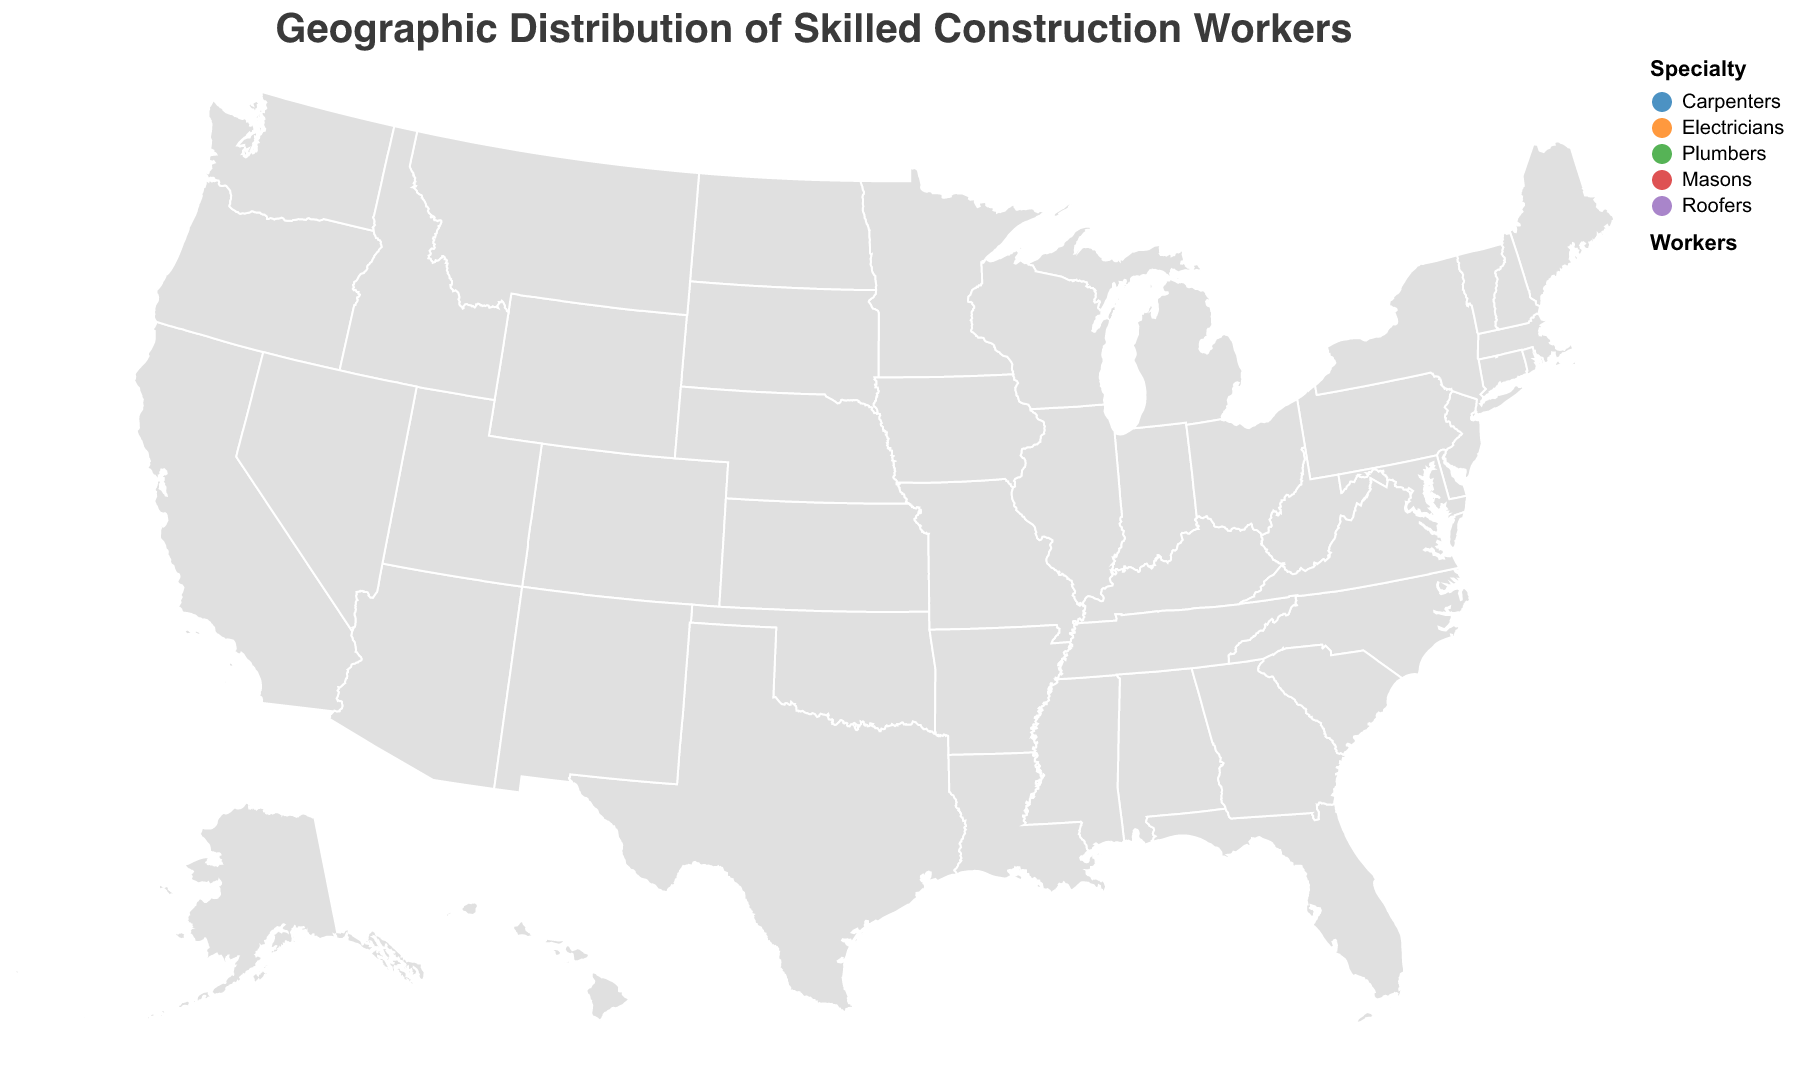What's the title of the figure? The title is written at the top of the figure and is descriptive of the data shown. The title for this figure is "Geographic Distribution of Skilled Construction Workers".
Answer: Geographic Distribution of Skilled Construction Workers Which state has the highest number of skilled carpenters? By looking at the circles representing carpenters in each state, the circle for California appears to be the largest, indicating it has the highest number of carpenters.
Answer: California What is the total number of electricians in Texas and Florida combined? Sum the number of electricians in Texas and Florida from the figure: 7200 (Texas) + 6500 (Florida), resulting in a total of 13700 electricians.
Answer: 13700 How do the number of masons in New York compare to the number in Ohio? Look at the circle sizes for masons in New York and Ohio. New York has 4700 masons while Ohio has 3500 masons. Thus, New York has 1200 more masons.
Answer: New York has more Which state has more plumbers, Illinois or Georgia? By comparing the circle sizes for plumbers in Illinois and Georgia, Georgia has 5000 plumbers while Illinois has 4600 plumbers, indicating Georgia has more plumbers.
Answer: Georgia Compare the number of roofers in Michigan and Pennsylvania. Which state has fewer? Check the circle sizes for roofers in Michigan and Pennsylvania. Michigan has 3000 roofers while Pennsylvania has 3300 roofers, indicating Michigan has fewer roofers.
Answer: Michigan Which specialty has the highest number of workers in Florida? Look at the different specialties for Florida. The largest circle size represents carpenters, so carpenters are the specialty with the highest number of workers in Florida.
Answer: Carpenters Is the distribution of roofers across the states more uniform or does it vary significantly? Assess the circle sizes for roofers in each state. The sizes differ notably, with California having the most (5600) and Michigan the least (3000), signifying a significant variation rather than a uniform distribution.
Answer: Vary significantly For which specialty is Pennsylvania ranked highest among the listed states? Compare Pennsylvania’s specialty counts against other states. Pennsylvania does not have the highest counts for any specialty when compared, so it is not ranked highest in any specialty.
Answer: None Summarize the geographic distribution trend of skilled construction workers in the figure. The figure shows that states like California and Texas have the largest numbers of skilled construction workers across all specialties, followed by states like Florida and New York, while states like Michigan and Illinois have comparatively fewer workers in these professions. This indicates a concentration of skilled construction workers in larger and possibly more economically vibrant states.
Answer: Concentrated in larger states like California and Texas 